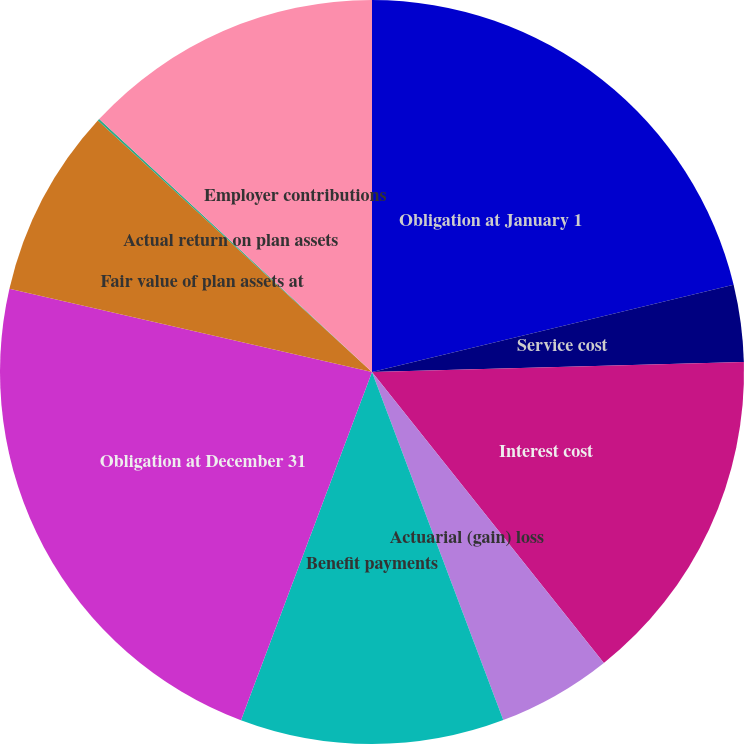<chart> <loc_0><loc_0><loc_500><loc_500><pie_chart><fcel>Obligation at January 1<fcel>Service cost<fcel>Interest cost<fcel>Actuarial (gain) loss<fcel>Benefit payments<fcel>Obligation at December 31<fcel>Fair value of plan assets at<fcel>Actual return on plan assets<fcel>Employer contributions<nl><fcel>21.23%<fcel>3.34%<fcel>14.72%<fcel>4.97%<fcel>11.47%<fcel>22.86%<fcel>8.22%<fcel>0.09%<fcel>13.1%<nl></chart> 